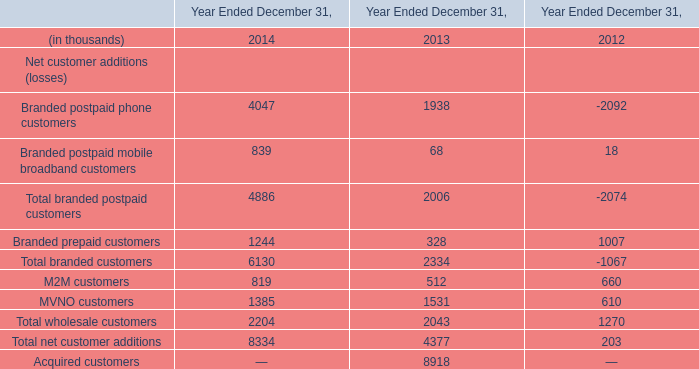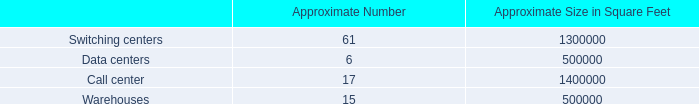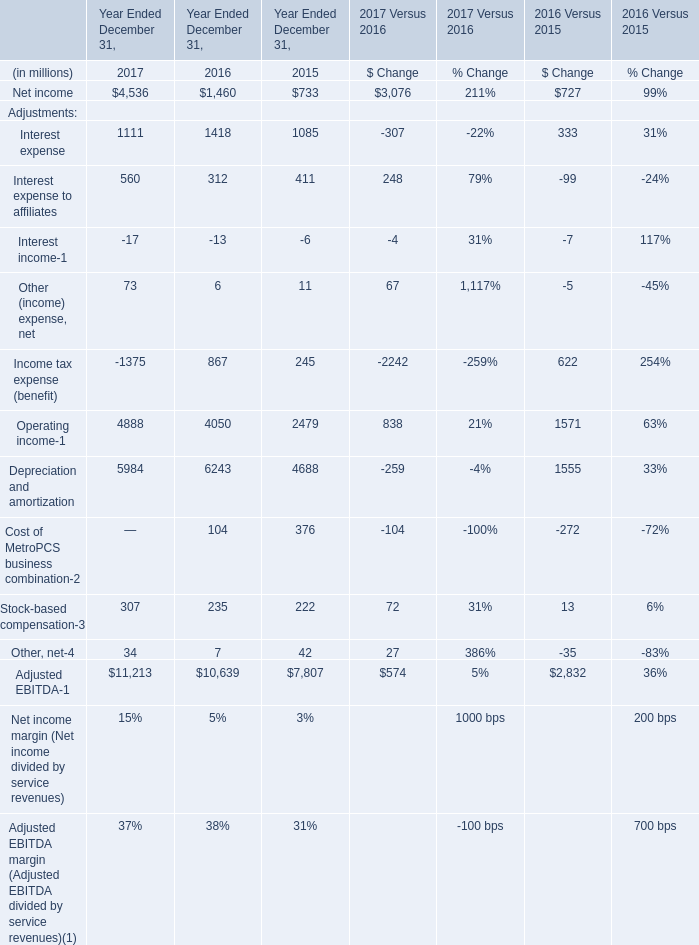What is the average value of Operating income for Adjustments in 2017, 2016, and 2015 for Year Ended December 31,? (in million) 
Computations: (((4888 + 4050) + 2479) / 3)
Answer: 3805.66667. 